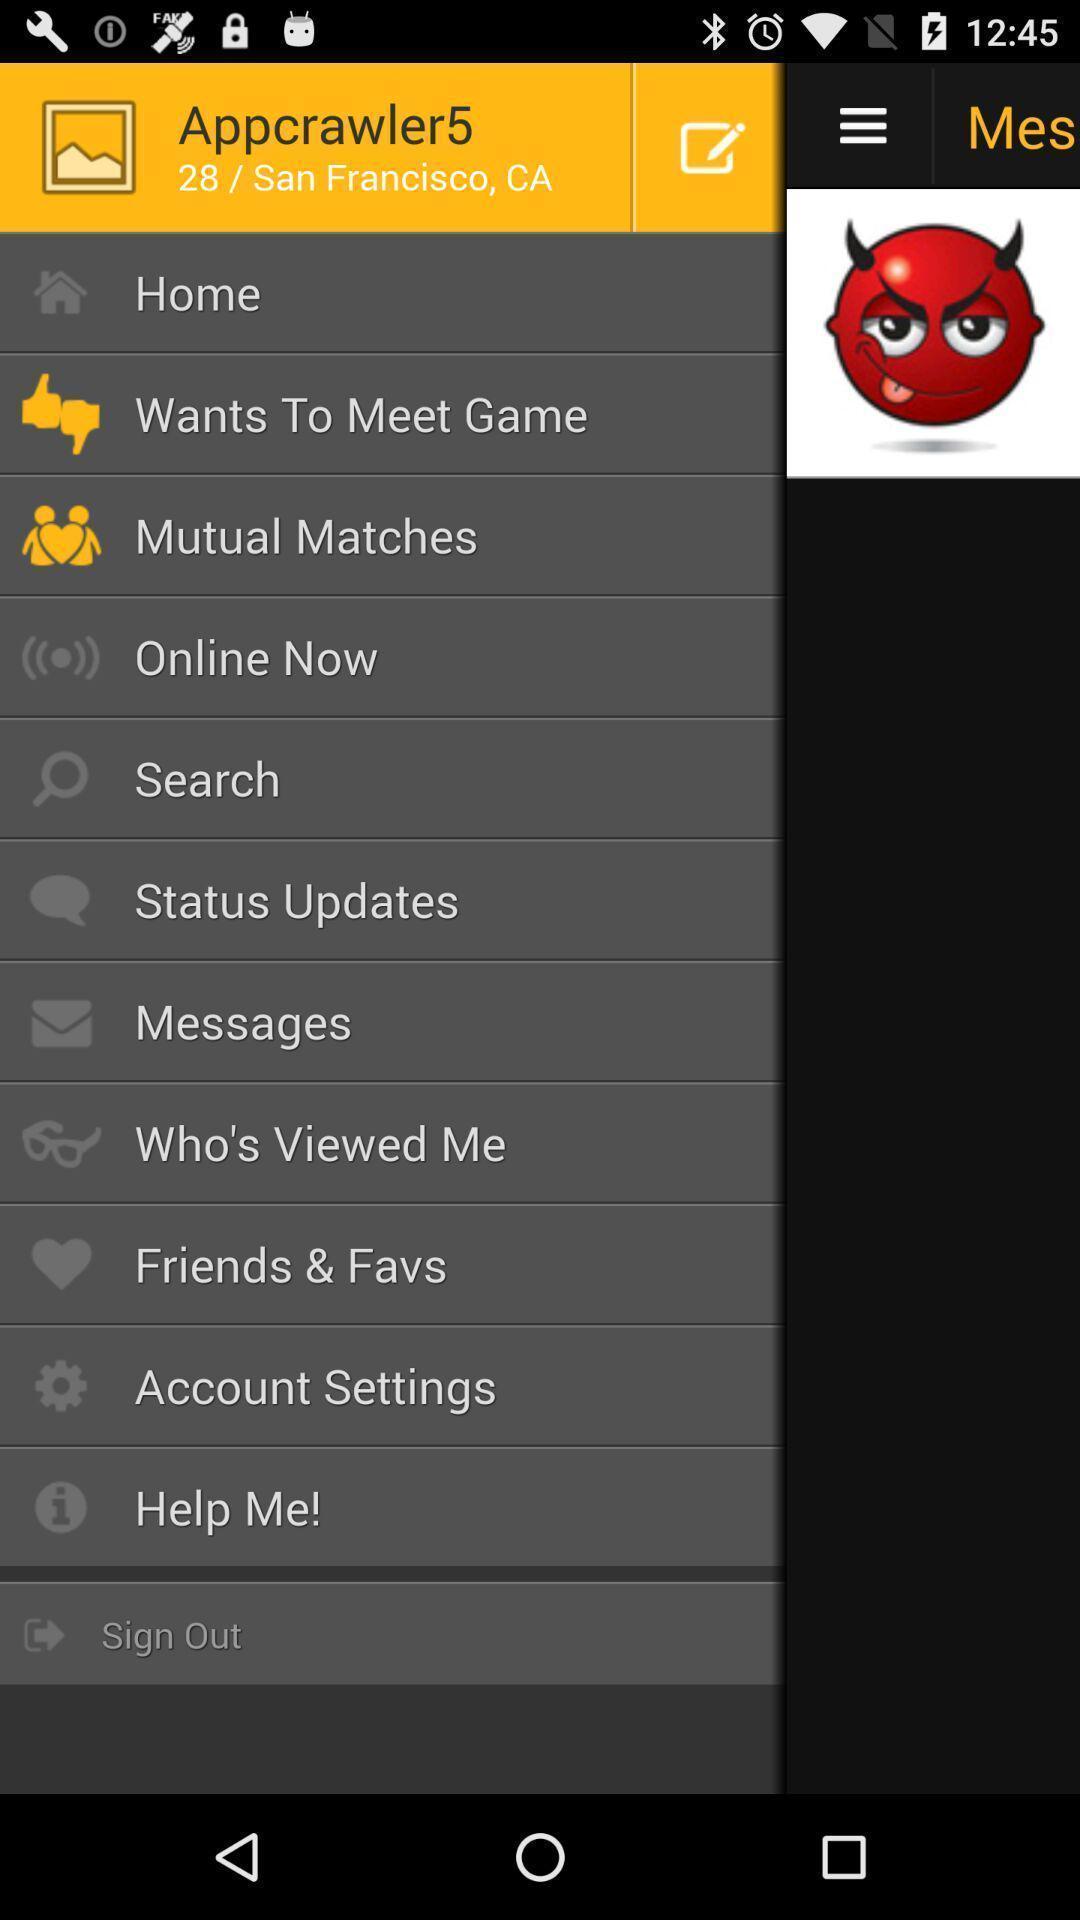Provide a description of this screenshot. Screen shows about home page settings. 